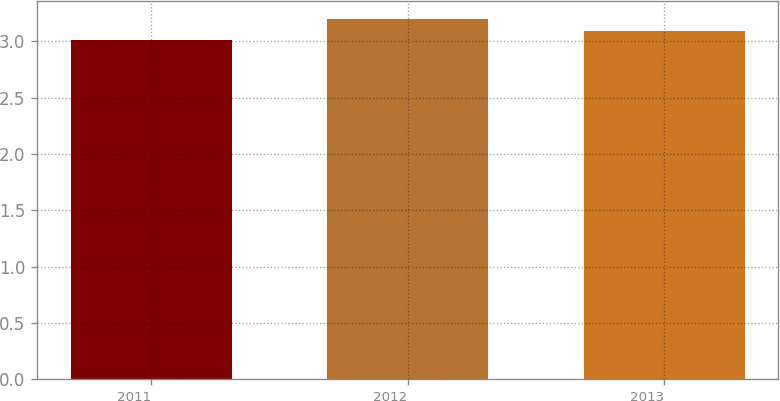Convert chart. <chart><loc_0><loc_0><loc_500><loc_500><bar_chart><fcel>2011<fcel>2012<fcel>2013<nl><fcel>3.01<fcel>3.2<fcel>3.09<nl></chart> 